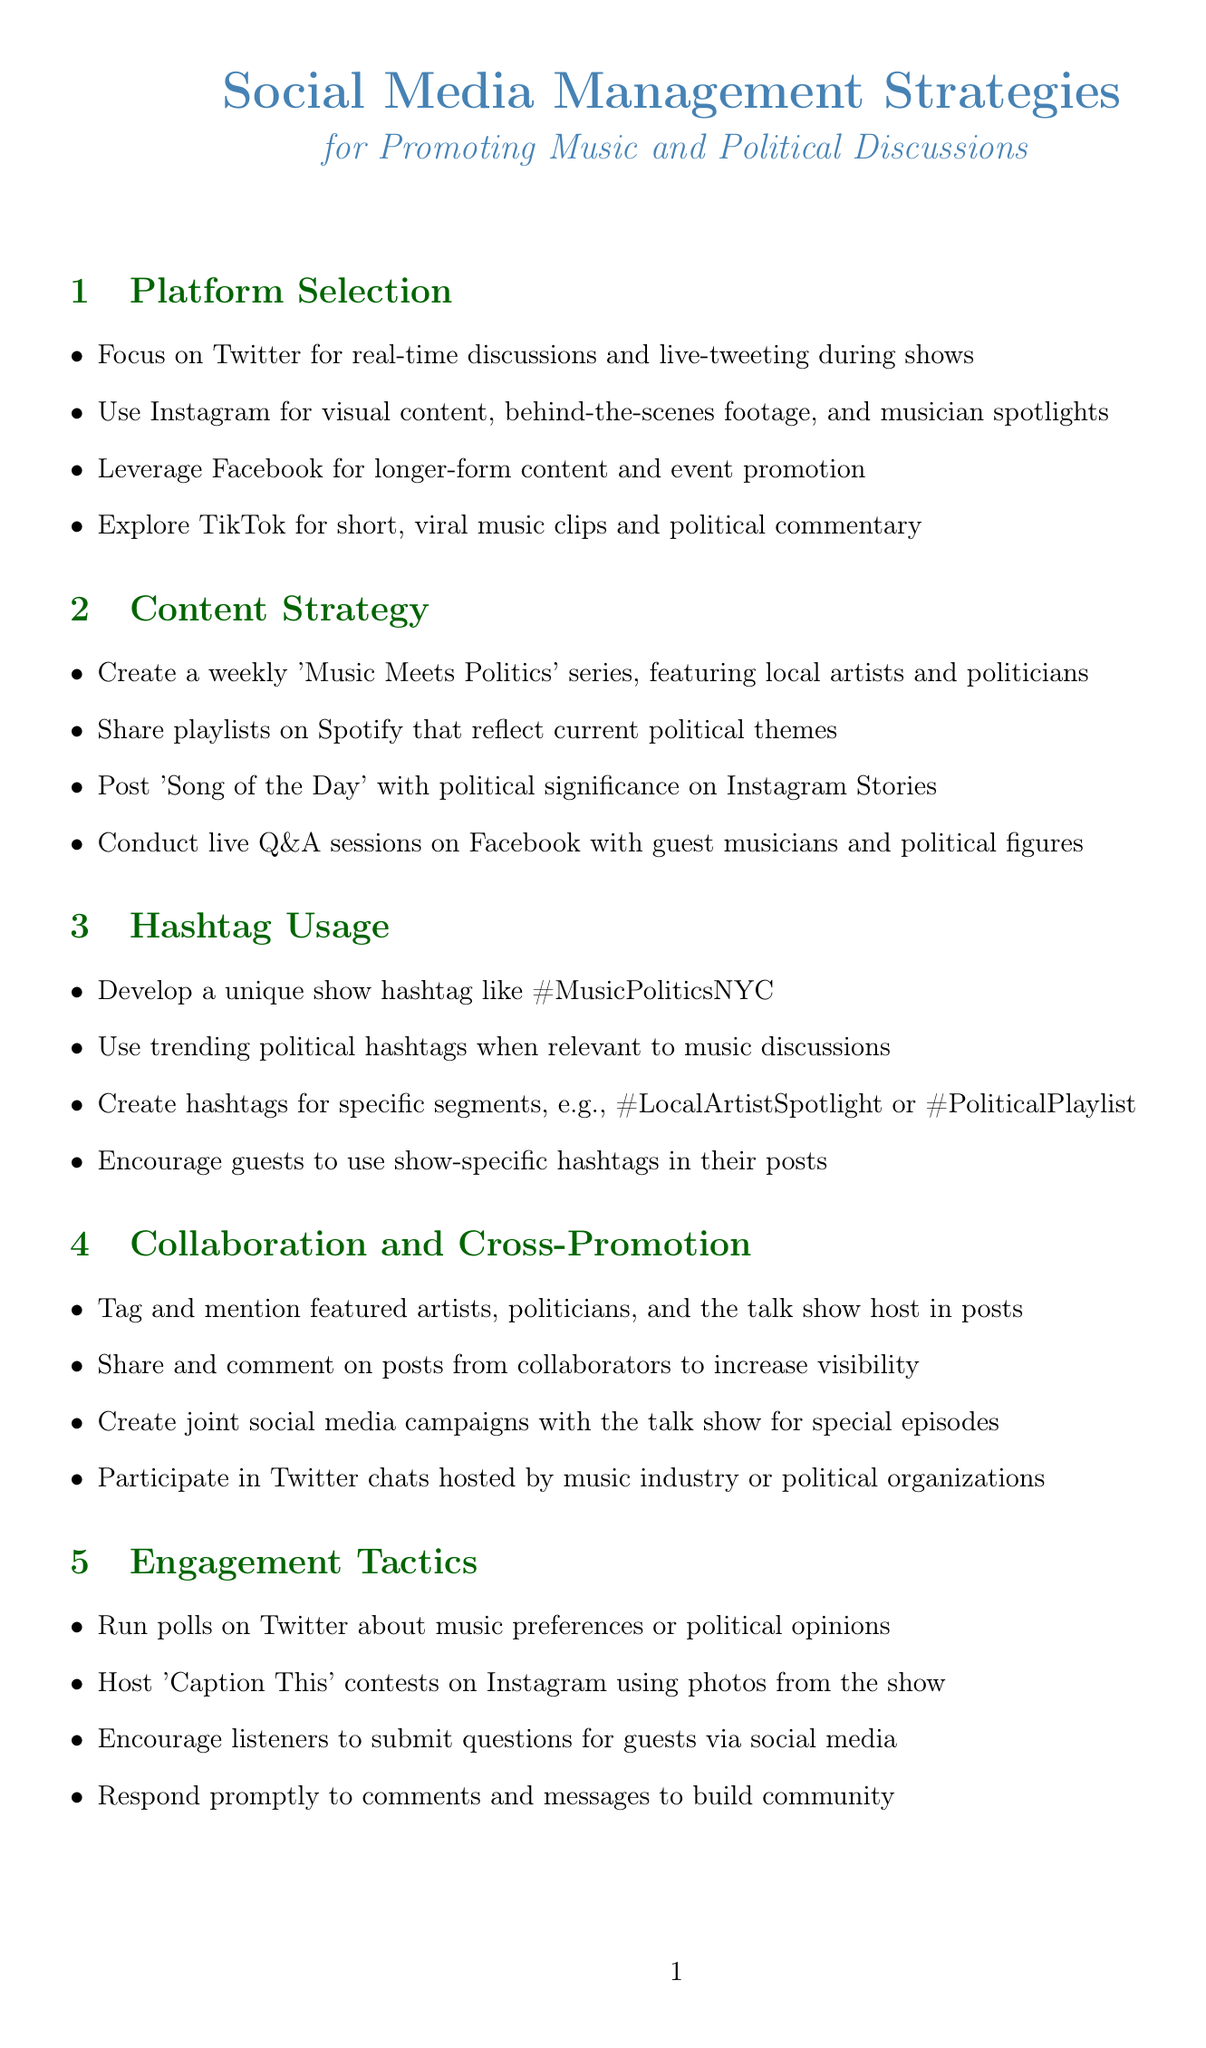What is the main title of the document? The main title is provided at the beginning of the document, detailing the focus on social media strategies for a specific context.
Answer: Social Media Management Strategies for Promoting Music and Political Discussions Which platform is recommended for real-time discussions? The document specifies which social media platform is the best fit for engaging in real-time conversations.
Answer: Twitter What is the unique show hashtag suggested? The document encourages the development of a particular hashtag for easy identification of discussions related to the show.
Answer: #MusicPoliticsNYC How often should the 'Music Meets Politics' series occur? The content strategy section mentions the frequency for this series featuring local artists and politicians.
Answer: Weekly What tactic is suggested for engaging the audience on Twitter? The engagement tactics section provides specific methods for interacting with viewers and listeners on this platform.
Answer: Run polls What should be clearly labeled in compliance and ethics? The document notes certain types of content that require clear identification to comply with legal standards.
Answer: Sponsored content Which social media platform is advised for visual content? The platform specifically suited for sharing images and behind-the-scenes footage is outlined in the document.
Answer: Instagram What is the suggested use of Facebook Ads? The document recommends specific ways to leverage Facebook's advertising tools for promotion purposes.
Answer: Promote special episodes or events How should political content comply legally? The compliance and ethics section addresses the requirements regarding legal adherence for political discussions.
Answer: FCC regulations 